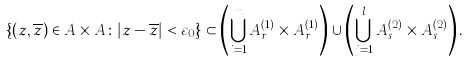<formula> <loc_0><loc_0><loc_500><loc_500>\{ ( z , \overline { z } ) \in A \times A \colon | z - \overline { z } | < \varepsilon _ { 0 } \} \subset \left ( \bigcup _ { i = 1 } ^ { m } A ^ { ( 1 ) } _ { r _ { i } } \times A ^ { ( 1 ) } _ { r _ { i } } \right ) \cup \left ( \bigcup _ { j = 1 } ^ { l } A ^ { ( 2 ) } _ { s _ { j } } \times A ^ { ( 2 ) } _ { s _ { j } } \right ) .</formula> 